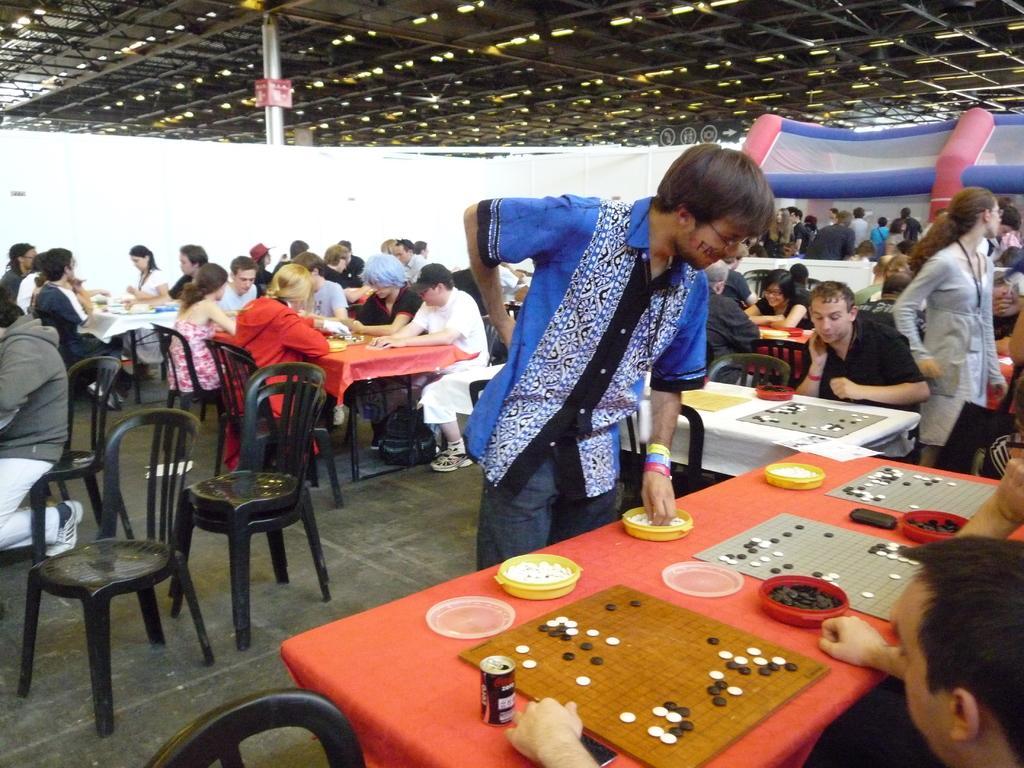Describe this image in one or two sentences. In this picture I can see number of people are sitting and few of them are standing. Here I can see number of tables. 